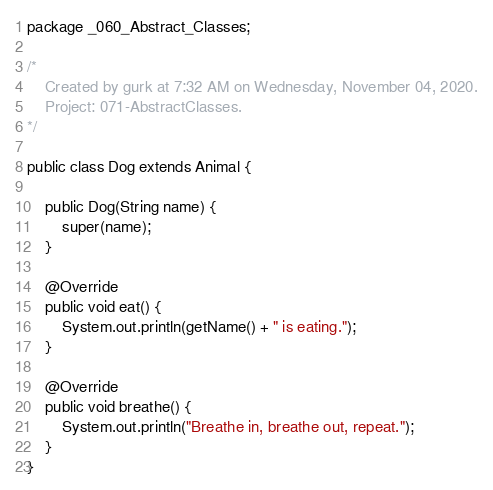Convert code to text. <code><loc_0><loc_0><loc_500><loc_500><_Java_>package _060_Abstract_Classes;

/*
    Created by gurk at 7:32 AM on Wednesday, November 04, 2020.
    Project: 071-AbstractClasses.
*/

public class Dog extends Animal {

    public Dog(String name) {
        super(name);
    }

    @Override
    public void eat() {
        System.out.println(getName() + " is eating.");
    }

    @Override
    public void breathe() {
        System.out.println("Breathe in, breathe out, repeat.");
    }
}
</code> 